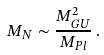Convert formula to latex. <formula><loc_0><loc_0><loc_500><loc_500>M _ { N } \sim \frac { M _ { G U } ^ { 2 } } { M _ { P l } } \, .</formula> 